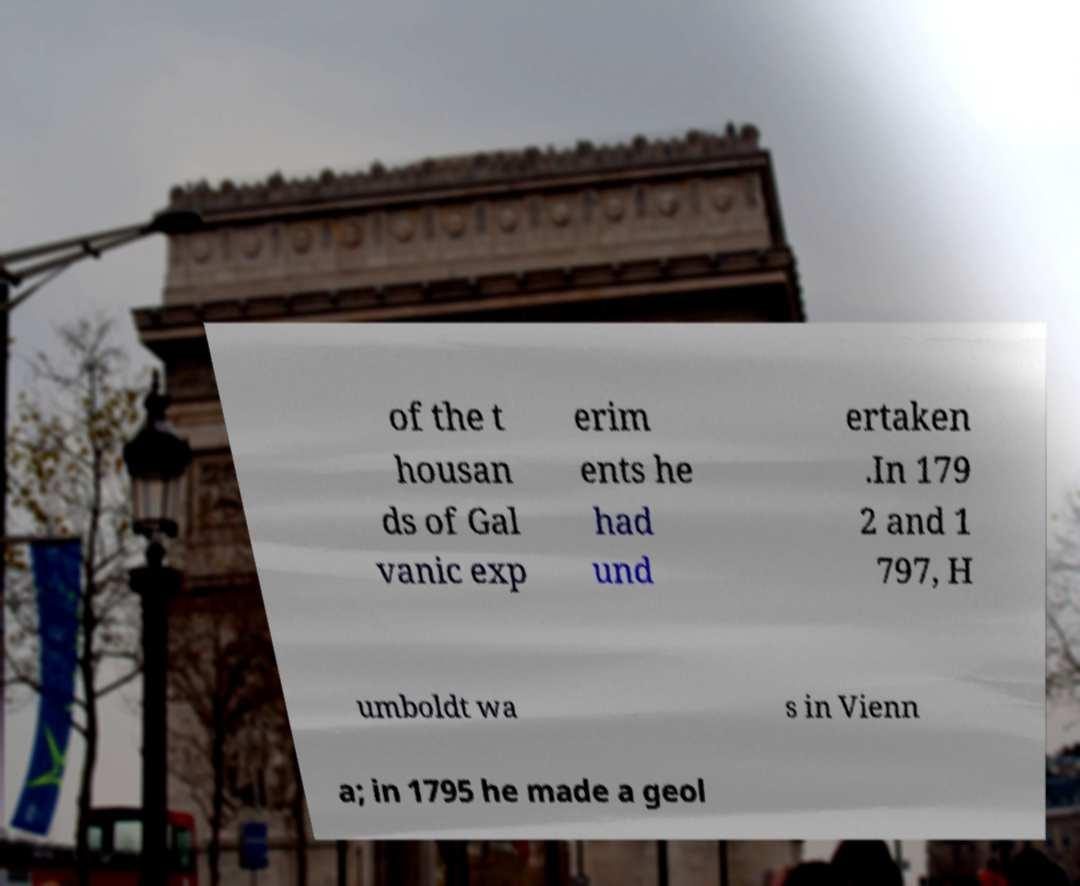Please read and relay the text visible in this image. What does it say? of the t housan ds of Gal vanic exp erim ents he had und ertaken .In 179 2 and 1 797, H umboldt wa s in Vienn a; in 1795 he made a geol 